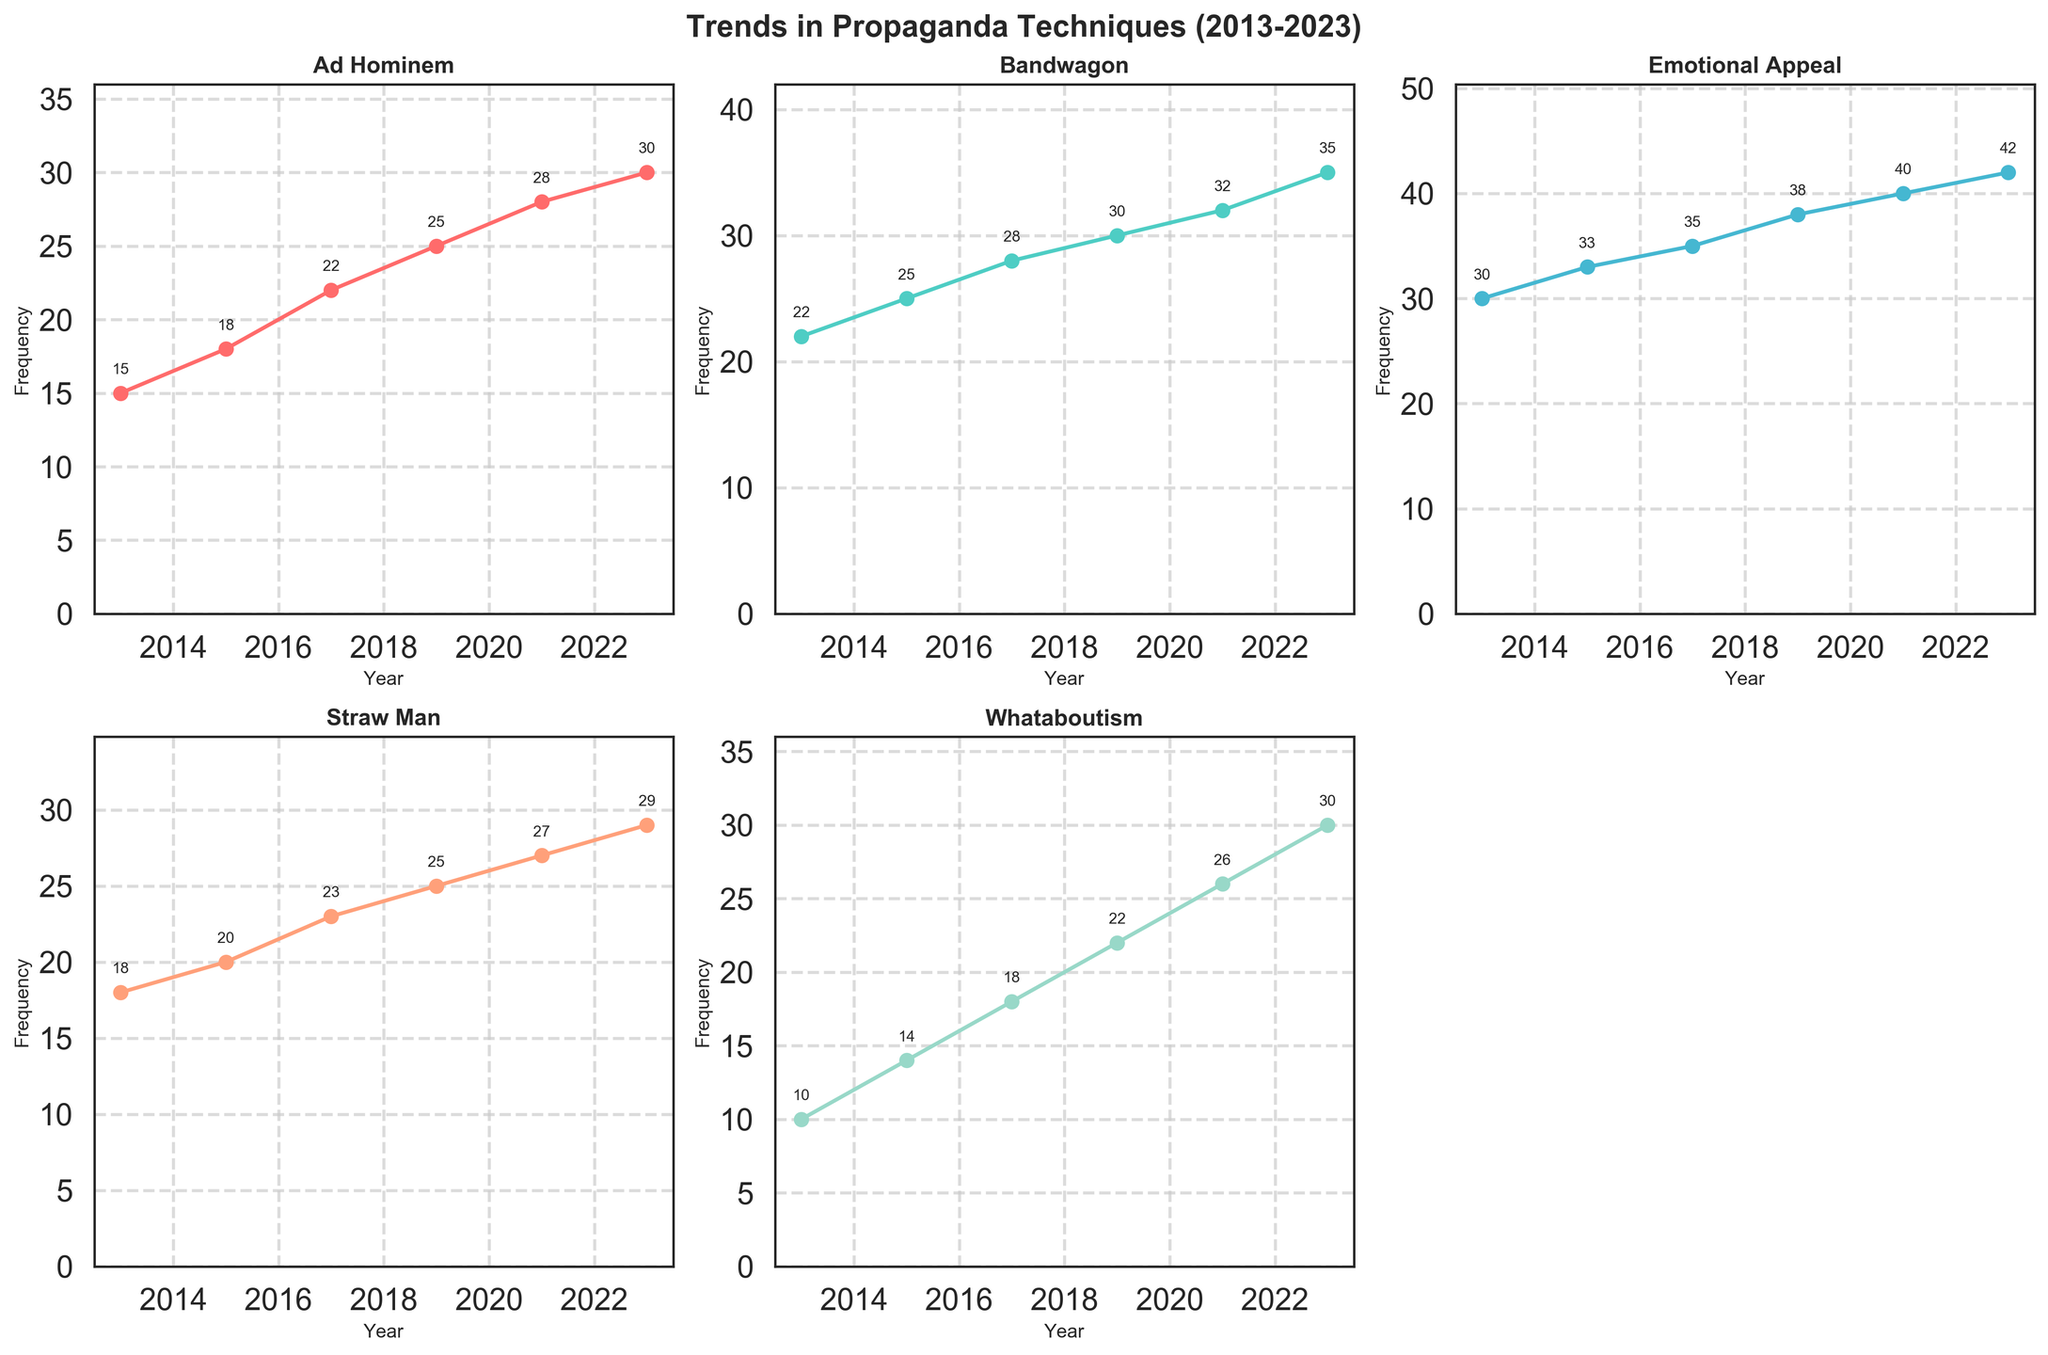How many propaganda techniques are displayed in the figure? The figure consists of 2 rows and 3 columns of subplots, covering a total of 5 different propaganda techniques mentioned in the legend. By counting the titles of the subplots, we identify: 'Ad Hominem', 'Bandwagon', 'Emotional Appeal', 'Straw Man', and 'Whataboutism'.
Answer: 5 Which year shows the highest use of the 'Whataboutism' technique? In the 'Whataboutism' subplot, each data point is labeled with its value. The highest value on the y-axis for 'Whataboutism' is in 2023, with a frequency of 30.
Answer: 2023 What is the increase in frequency of the 'Ad Hominem' technique from 2013 to 2023? Subtract the frequency of 'Ad Hominem' in 2013 from its frequency in 2023: 30 (2023) - 15 (2013) = 15.
Answer: 15 Which technique has the most consistent upward trend? By visually analyzing the trends in all subplots, it appears that all techniques show an upward trend, but 'Emotional Appeal' has the most consistent, steady increase in frequency without any significant dips.
Answer: Emotional Appeal Compare the frequency of 'Bandwagon' and 'Straw Man' techniques in 2019. Which one was used more frequently? From the subplots, the frequency of 'Bandwagon' in 2019 is 30, while the frequency of 'Straw Man' in the same year is 25. By comparing these values, 'Bandwagon' was used more frequently than 'Straw Man' in 2019.
Answer: Bandwagon What is the overall trend of the frequency of the 'Straw Man' technique from 2013 to 2023? By looking at the 'Straw Man' subplot, the frequency increases steadily from 18 in 2013 to 29 in 2023. This upward trend indicates a rise in the use of the 'Straw Man' technique over the decade.
Answer: Upward trend Calculate the average frequency of the 'Emotional Appeal' technique over the years presented. Sum the frequencies of 'Emotional Appeal' across all years and divide by the number of years. (30 + 33 + 35 + 38 + 40 + 42) / 6 = 218 / 6 = 36.33.
Answer: 36.33 Which technique had the least frequency in 2015? By comparing the frequencies of all techniques in the 2015 subplots, 'Whataboutism' had the lowest frequency at 14.
Answer: Whataboutism Is there any year where the 'Bandwagon' and 'Ad Hominem' technique frequencies are equal? Checking each year individually in the subplots, there is no year where the frequencies of 'Bandwagon' and 'Ad Hominem' are the same.
Answer: No 